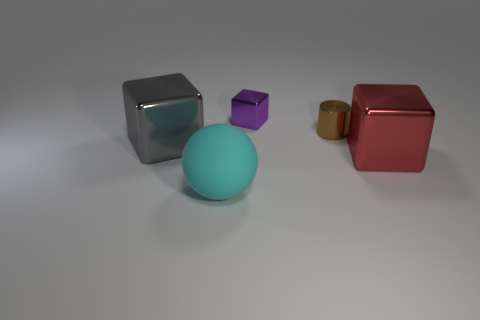Subtract all large gray shiny cubes. How many cubes are left? 2 Add 5 gray objects. How many objects exist? 10 Subtract all gray blocks. How many blocks are left? 2 Subtract 0 brown spheres. How many objects are left? 5 Subtract all spheres. How many objects are left? 4 Subtract 1 cylinders. How many cylinders are left? 0 Subtract all red cylinders. Subtract all green balls. How many cylinders are left? 1 Subtract all tiny brown metallic objects. Subtract all purple metallic things. How many objects are left? 3 Add 3 big things. How many big things are left? 6 Add 2 tiny brown objects. How many tiny brown objects exist? 3 